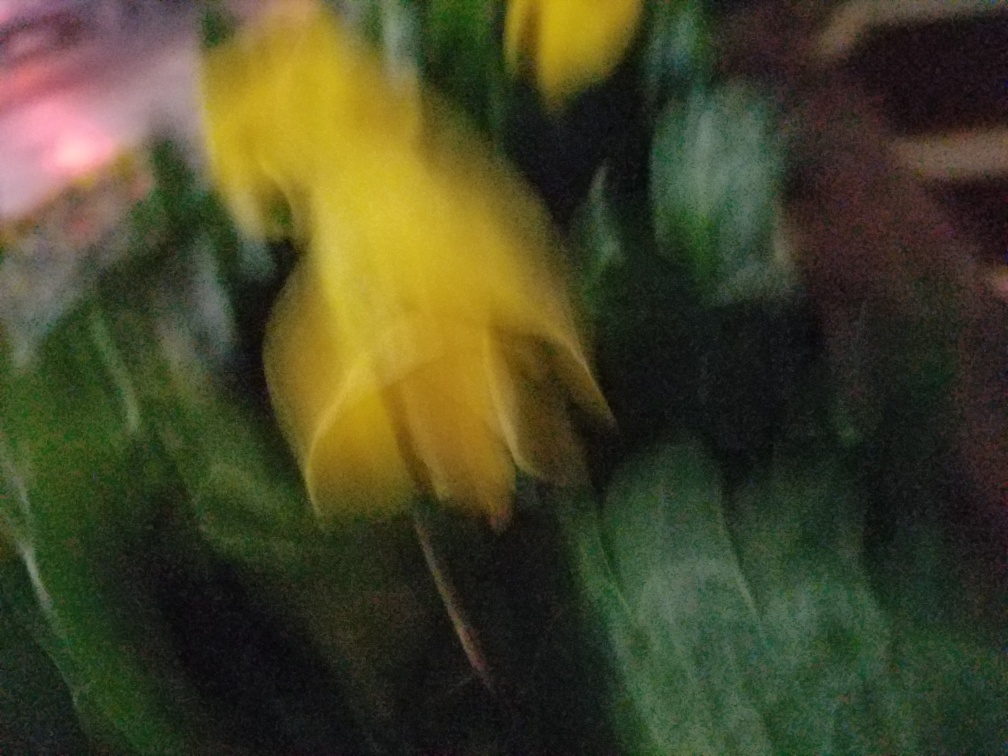What might be the cause of the blur in this photograph? The blur in the photo could be due to several factors, such as motion—either the subject moving or the camera shaking during the shot. It might also result from an incorrect focus setting or taking the photo at a slow shutter speed without a stable support for the camera. 